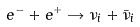Convert formula to latex. <formula><loc_0><loc_0><loc_500><loc_500>e ^ { - } + e ^ { + } \rightarrow \nu _ { i } + \bar { \nu } _ { i }</formula> 